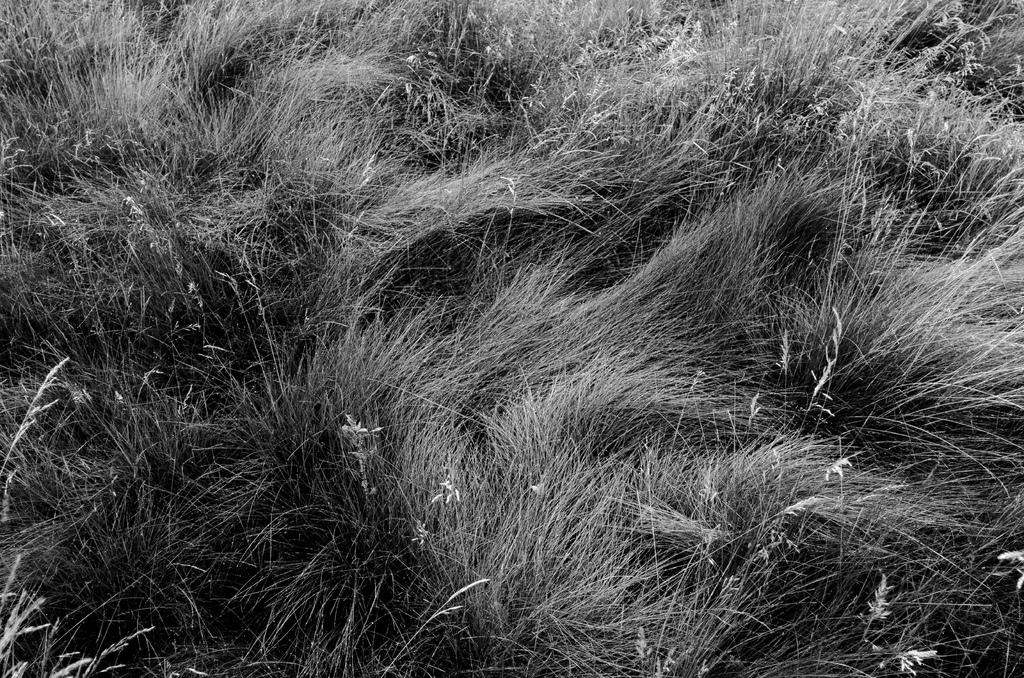What is the color scheme of the image? The image is black and white. What type of vegetation can be seen in the image? There is grass visible in the image. What type of writing can be seen on the grass in the image? There is no writing present on the grass in the image. What scent is associated with the grass in the image? The image is a visual representation and does not convey scents, so it is not possible to determine the scent of the grass from the image. 